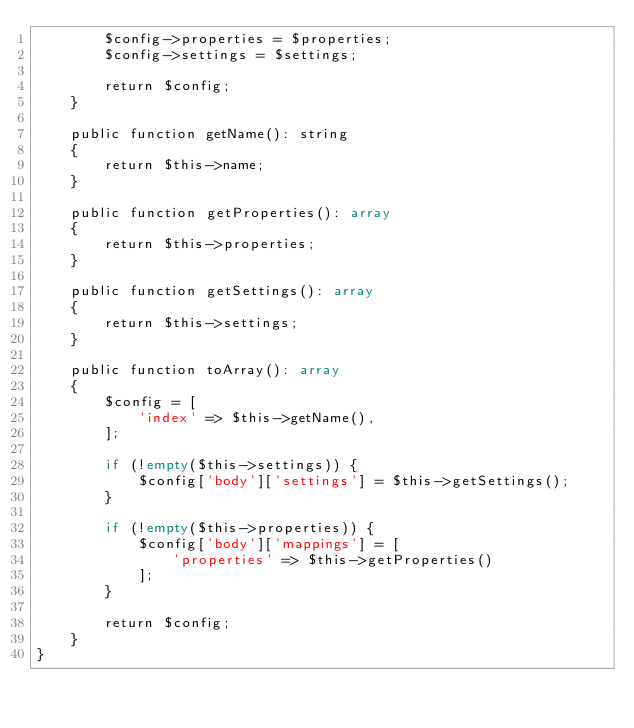Convert code to text. <code><loc_0><loc_0><loc_500><loc_500><_PHP_>        $config->properties = $properties;
        $config->settings = $settings;

        return $config;
    }

    public function getName(): string
    {
        return $this->name;
    }

    public function getProperties(): array
    {
        return $this->properties;
    }

    public function getSettings(): array
    {
        return $this->settings;
    }

    public function toArray(): array
    {
        $config = [
            'index' => $this->getName(),
        ];

        if (!empty($this->settings)) {
            $config['body']['settings'] = $this->getSettings();
        }

        if (!empty($this->properties)) {
            $config['body']['mappings'] = [
                'properties' => $this->getProperties()
            ];
        }

        return $config;
    }
}
</code> 